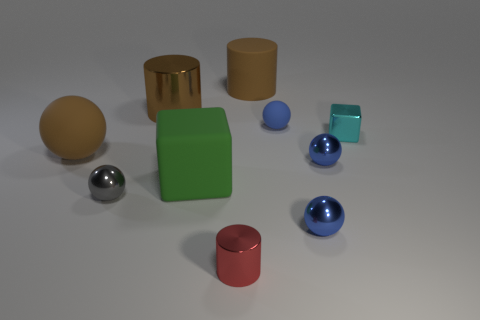Subtract all yellow blocks. How many blue balls are left? 3 Subtract 3 balls. How many balls are left? 2 Subtract all large cylinders. How many cylinders are left? 1 Subtract all brown balls. How many balls are left? 4 Subtract all green balls. Subtract all yellow blocks. How many balls are left? 5 Subtract 0 red spheres. How many objects are left? 10 Subtract all cylinders. How many objects are left? 7 Subtract all large rubber objects. Subtract all large brown spheres. How many objects are left? 6 Add 2 big green matte objects. How many big green matte objects are left? 3 Add 9 tiny yellow shiny balls. How many tiny yellow shiny balls exist? 9 